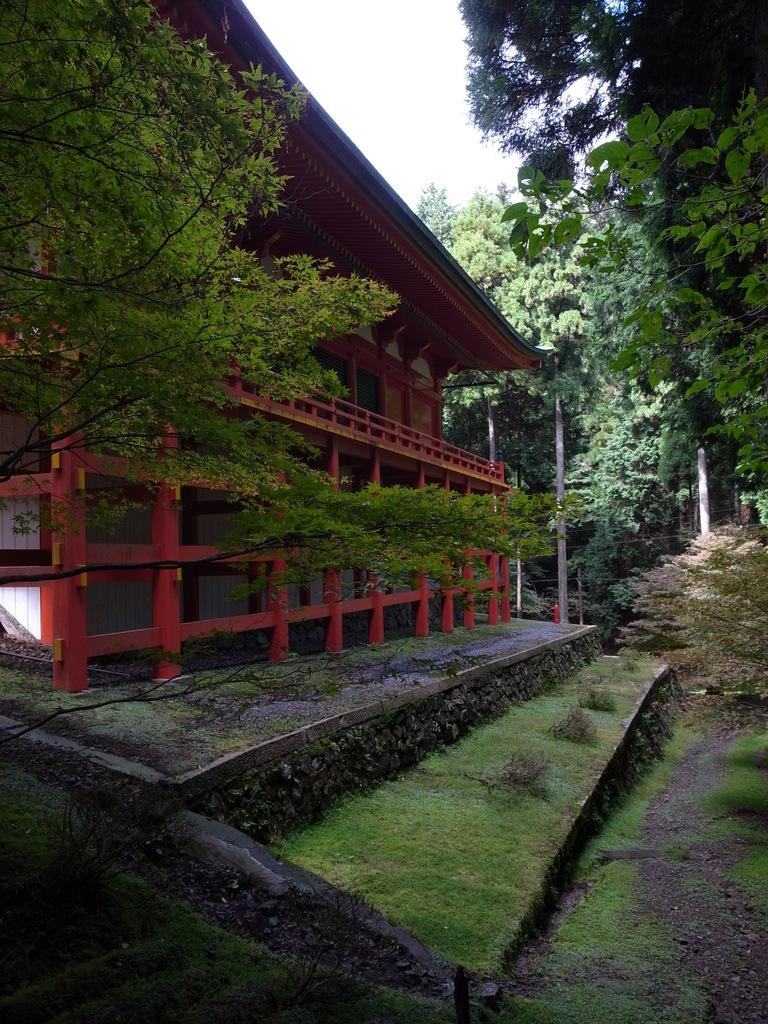What type of structure is present in the image? There is a house in the image. What can be seen near the house? There is a railing in the image. What type of vegetation is visible in the image? There are trees, plants, and grass in the image. What part of the natural environment is visible in the image? The sky is visible in the image. What type of development is taking place in the image? There is no development project visible in the image; it primarily features a house, vegetation, and the sky. 